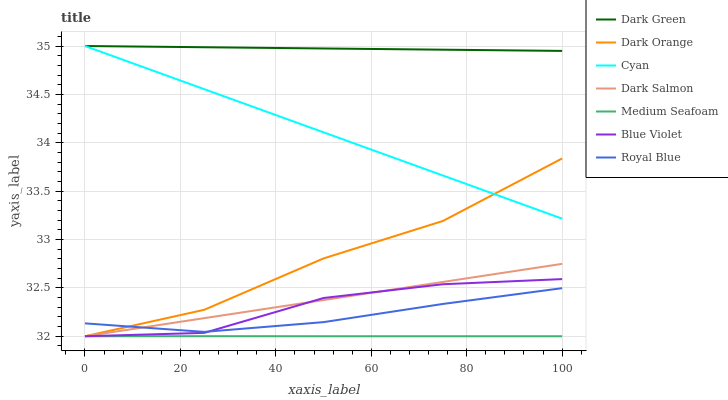Does Medium Seafoam have the minimum area under the curve?
Answer yes or no. Yes. Does Dark Green have the maximum area under the curve?
Answer yes or no. Yes. Does Dark Salmon have the minimum area under the curve?
Answer yes or no. No. Does Dark Salmon have the maximum area under the curve?
Answer yes or no. No. Is Dark Salmon the smoothest?
Answer yes or no. Yes. Is Dark Orange the roughest?
Answer yes or no. Yes. Is Royal Blue the smoothest?
Answer yes or no. No. Is Royal Blue the roughest?
Answer yes or no. No. Does Dark Orange have the lowest value?
Answer yes or no. Yes. Does Royal Blue have the lowest value?
Answer yes or no. No. Does Dark Green have the highest value?
Answer yes or no. Yes. Does Dark Salmon have the highest value?
Answer yes or no. No. Is Dark Salmon less than Dark Green?
Answer yes or no. Yes. Is Cyan greater than Blue Violet?
Answer yes or no. Yes. Does Royal Blue intersect Dark Orange?
Answer yes or no. Yes. Is Royal Blue less than Dark Orange?
Answer yes or no. No. Is Royal Blue greater than Dark Orange?
Answer yes or no. No. Does Dark Salmon intersect Dark Green?
Answer yes or no. No. 